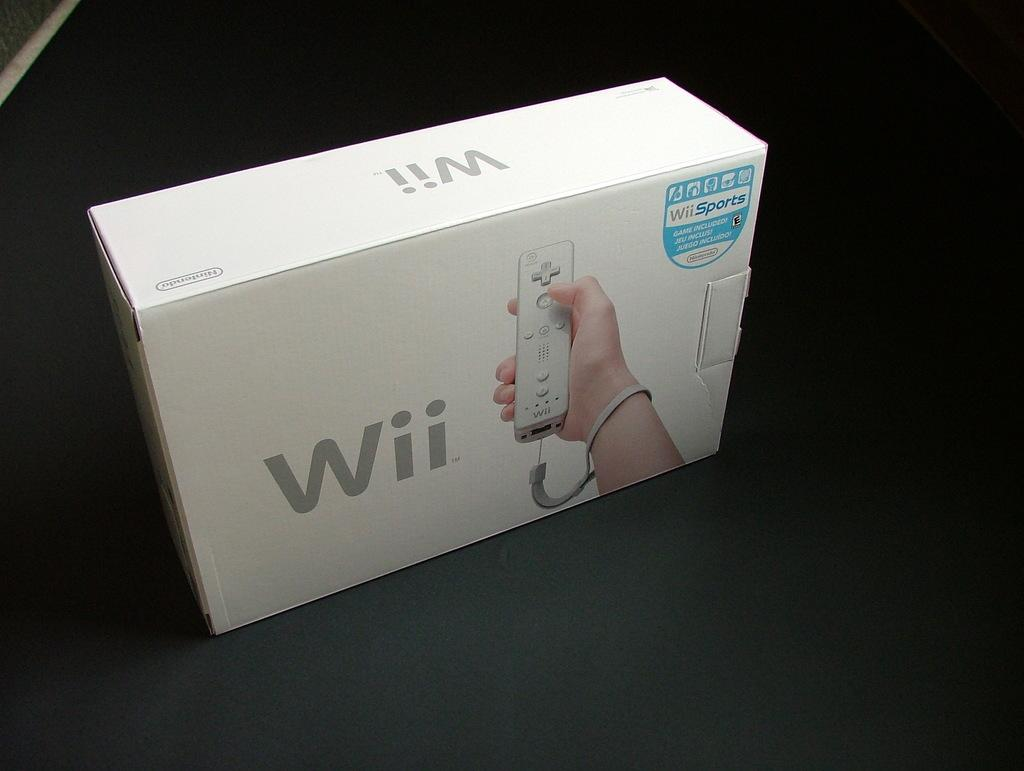Provide a one-sentence caption for the provided image. An original Wii box that has the game wiisports included. 